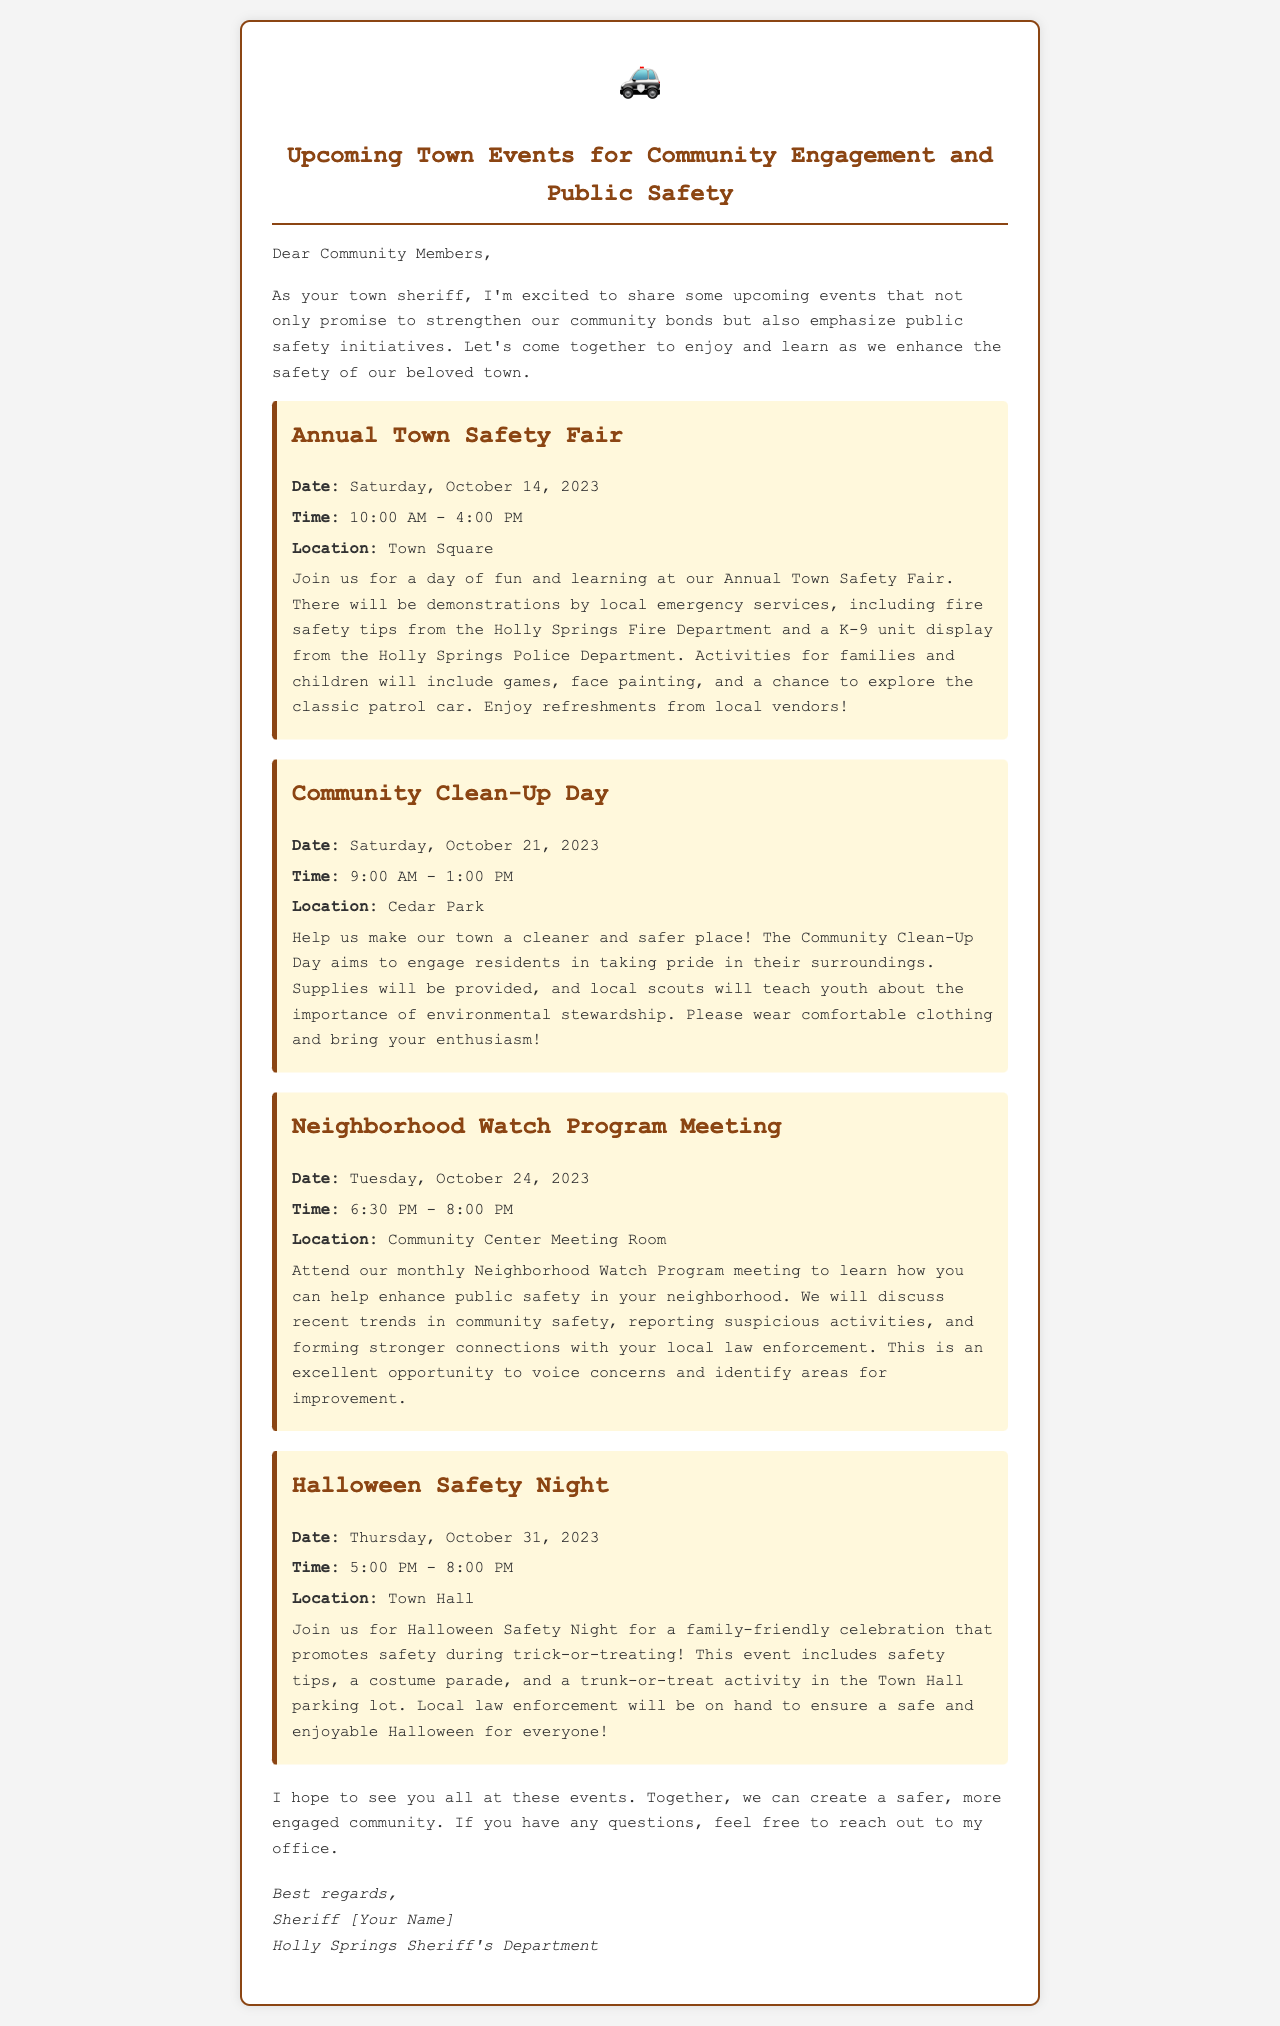What is the date of the Annual Town Safety Fair? The date for the Annual Town Safety Fair is explicitly mentioned in the document as Saturday, October 14, 2023.
Answer: Saturday, October 14, 2023 What event takes place on October 21, 2023? The document states that the Community Clean-Up Day is scheduled for October 21, 2023.
Answer: Community Clean-Up Day Where will the Neighborhood Watch Program Meeting be held? The document specifies that the meeting will take place in the Community Center Meeting Room.
Answer: Community Center Meeting Room What time does Halloween Safety Night start? The document provides the start time for Halloween Safety Night as 5:00 PM.
Answer: 5:00 PM What is the main focus of the Community Clean-Up Day? The document indicates that the focus is on engaging residents in taking pride in their surroundings.
Answer: Taking pride in their surroundings How long is the Annual Town Safety Fair? The document mentions that the fair runs from 10:00 AM to 4:00 PM, indicating a duration of 6 hours.
Answer: 6 hours What activities will happen at the Halloween Safety Night? The document outlines several activities, including safety tips, a costume parade, and trunk-or-treat.
Answer: Safety tips, costume parade, trunk-or-treat What types of demonstrations will occur at the Annual Town Safety Fair? The document lists demonstrations by local emergency services and fire safety tips as part of the fair.
Answer: Local emergency services demonstrations, fire safety tips What is the purpose of the Neighborhood Watch Program meeting? The document specifies that the purpose is to enhance public safety in the neighborhood and discuss community safety trends.
Answer: Enhance public safety in the neighborhood 